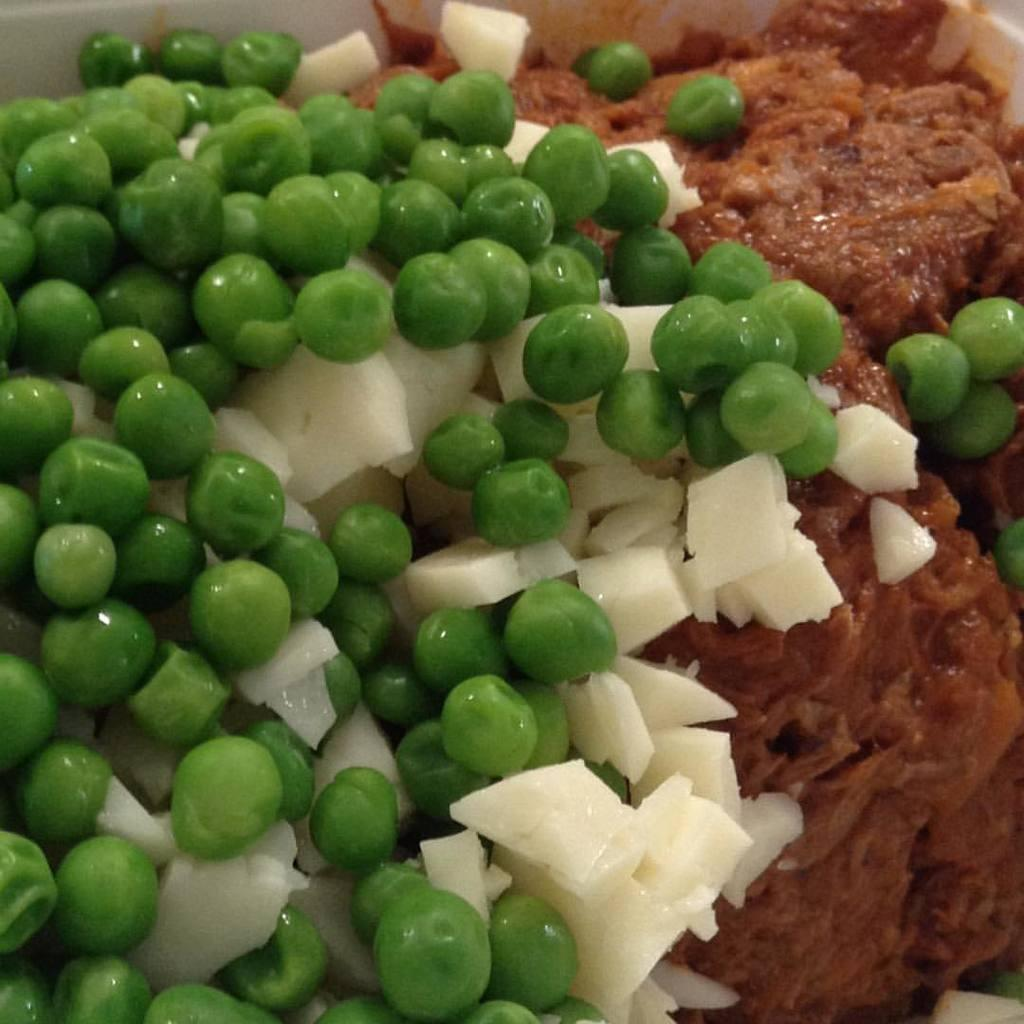What type of food can be seen in the image? There are green peas in the image. Are there any other food items visible in the image? Yes, there are other food items in the image. What type of vein is present in the image? There are no veins present in the image, as it features food items like green peas. 